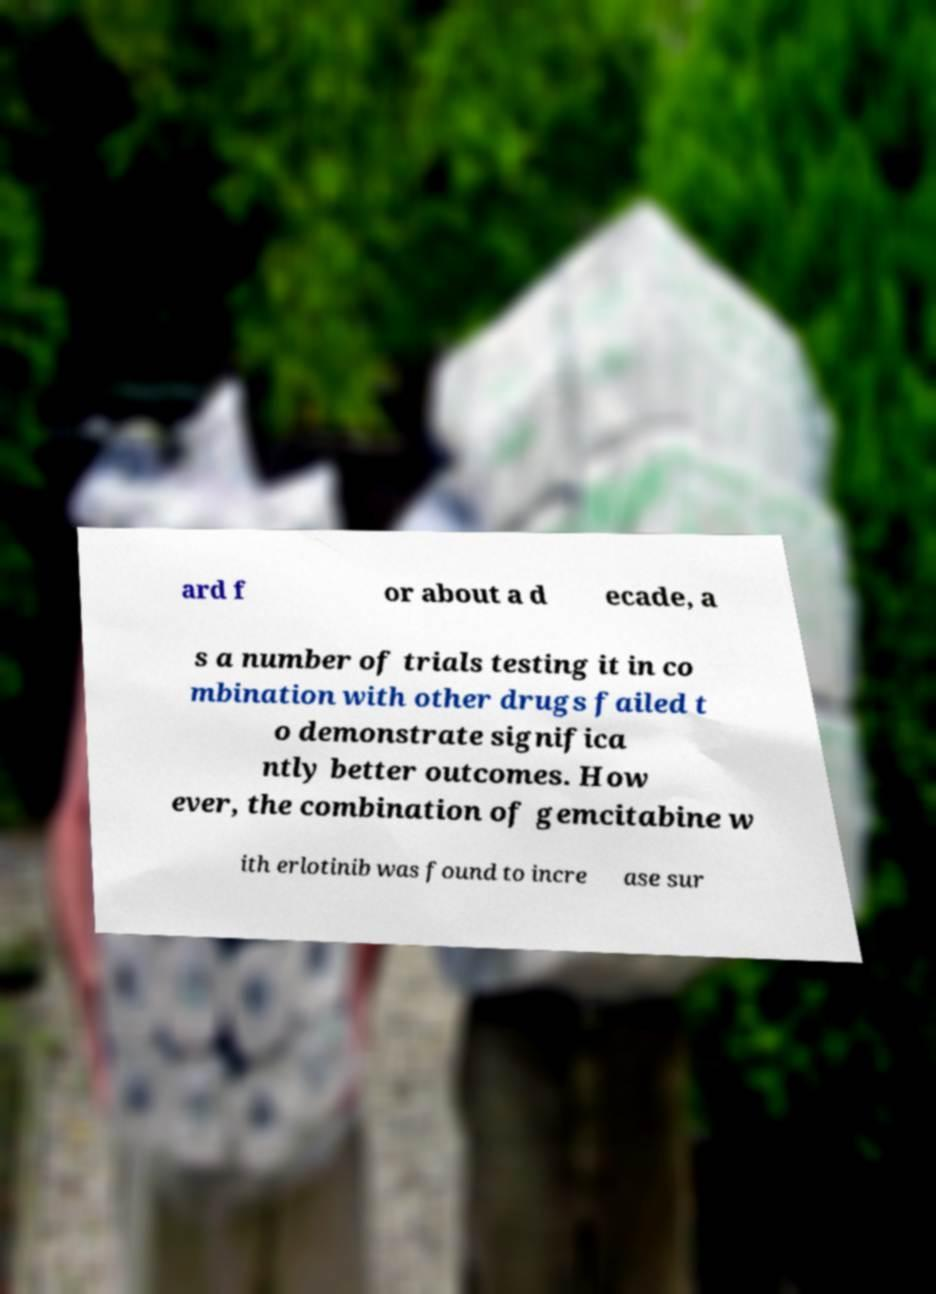Can you read and provide the text displayed in the image?This photo seems to have some interesting text. Can you extract and type it out for me? ard f or about a d ecade, a s a number of trials testing it in co mbination with other drugs failed t o demonstrate significa ntly better outcomes. How ever, the combination of gemcitabine w ith erlotinib was found to incre ase sur 